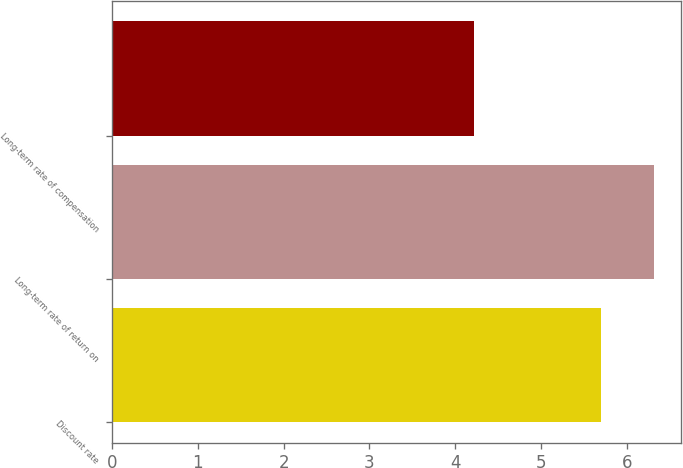Convert chart. <chart><loc_0><loc_0><loc_500><loc_500><bar_chart><fcel>Discount rate<fcel>Long-term rate of return on<fcel>Long-term rate of compensation<nl><fcel>5.7<fcel>6.32<fcel>4.22<nl></chart> 